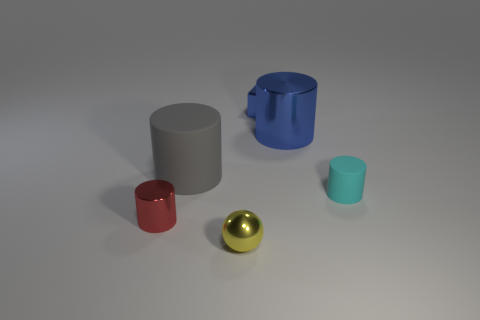There is a big metal cylinder; is its color the same as the tiny object that is on the left side of the big gray rubber cylinder?
Your answer should be compact. No. Are there any other things that are the same material as the block?
Ensure brevity in your answer.  Yes. There is a blue metal object that is left of the large cylinder that is on the right side of the yellow ball; what is its shape?
Offer a terse response. Cube. The metal thing that is the same color as the metallic cube is what size?
Provide a succinct answer. Large. There is a matte thing to the left of the cyan cylinder; is its shape the same as the red metal thing?
Make the answer very short. Yes. Are there more gray objects that are right of the cyan cylinder than tiny red metal objects that are on the right side of the blue metallic block?
Offer a terse response. No. There is a shiny cylinder in front of the large metallic cylinder; what number of red cylinders are to the right of it?
Your answer should be very brief. 0. There is a big thing that is the same color as the block; what is it made of?
Ensure brevity in your answer.  Metal. How many other things are the same color as the small metal cube?
Keep it short and to the point. 1. What color is the thing in front of the red object that is behind the tiny yellow object?
Offer a terse response. Yellow. 